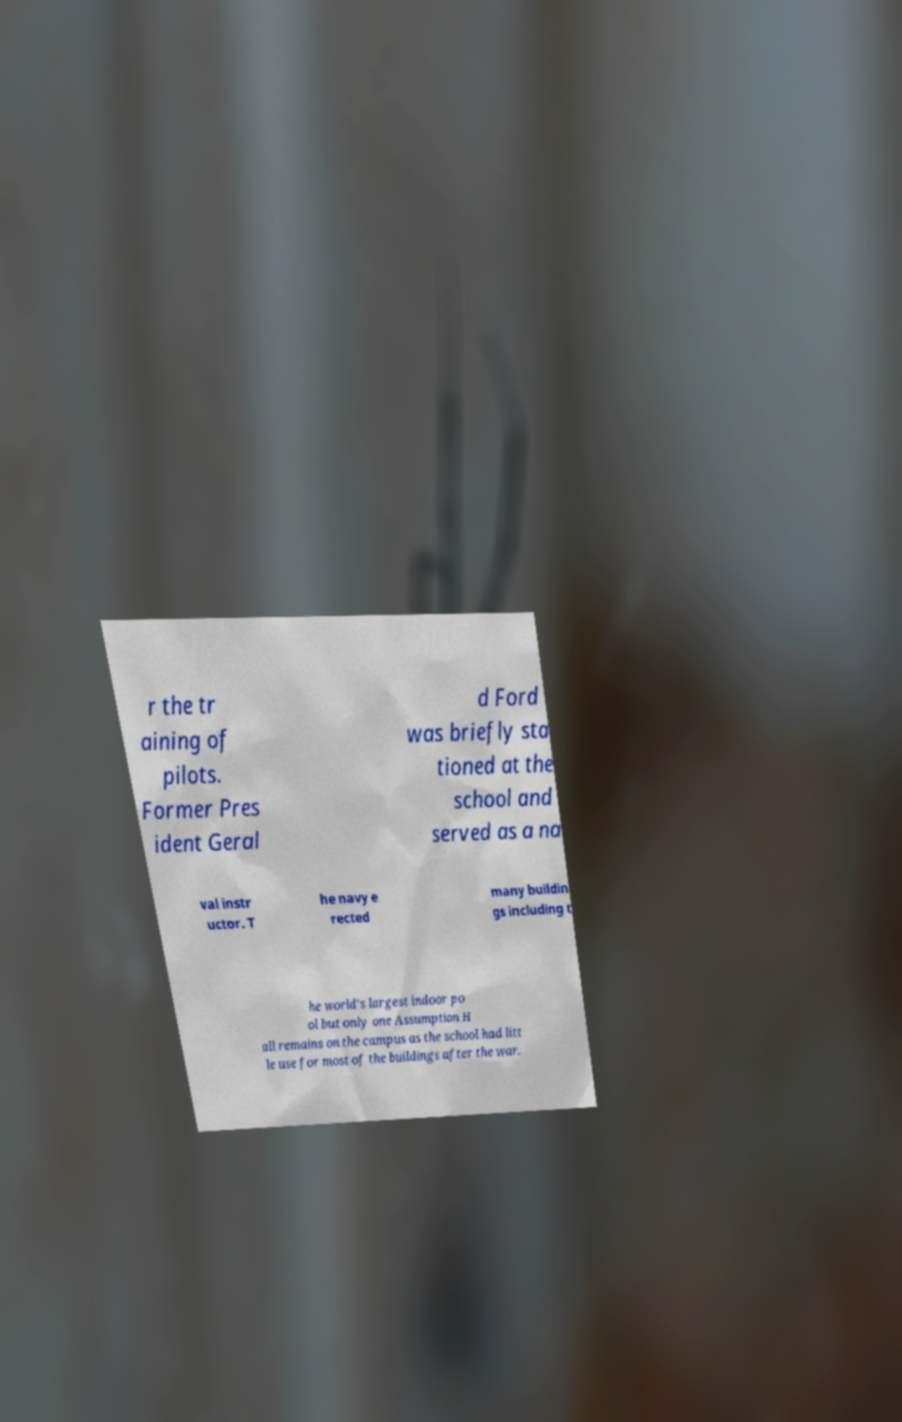Please identify and transcribe the text found in this image. r the tr aining of pilots. Former Pres ident Geral d Ford was briefly sta tioned at the school and served as a na val instr uctor. T he navy e rected many buildin gs including t he world's largest indoor po ol but only one Assumption H all remains on the campus as the school had litt le use for most of the buildings after the war. 